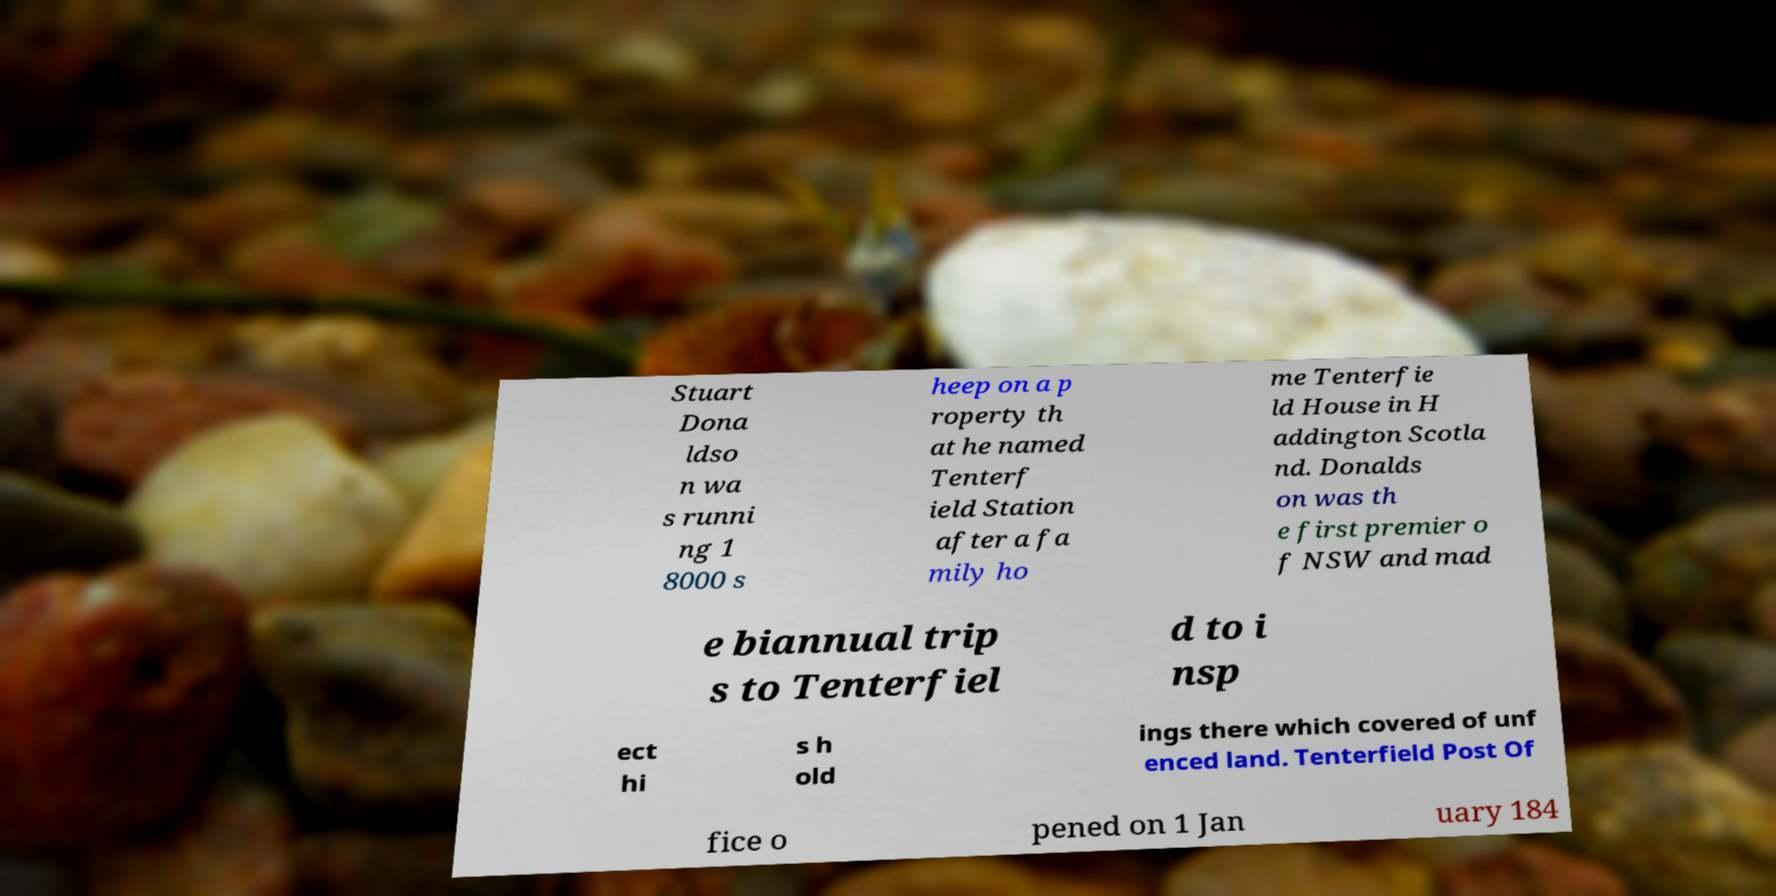Please read and relay the text visible in this image. What does it say? Stuart Dona ldso n wa s runni ng 1 8000 s heep on a p roperty th at he named Tenterf ield Station after a fa mily ho me Tenterfie ld House in H addington Scotla nd. Donalds on was th e first premier o f NSW and mad e biannual trip s to Tenterfiel d to i nsp ect hi s h old ings there which covered of unf enced land. Tenterfield Post Of fice o pened on 1 Jan uary 184 